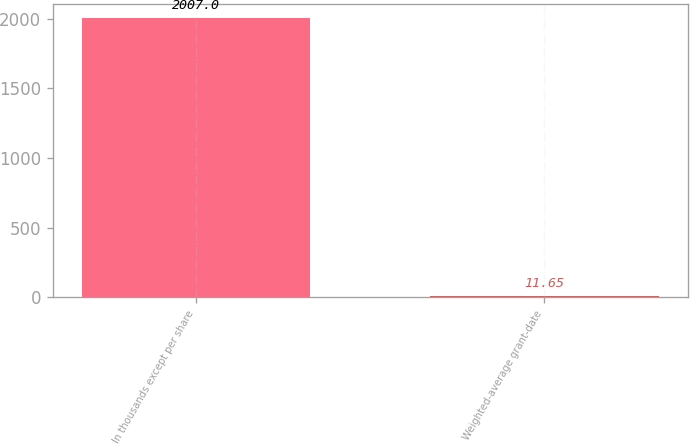Convert chart. <chart><loc_0><loc_0><loc_500><loc_500><bar_chart><fcel>In thousands except per share<fcel>Weighted-average grant-date<nl><fcel>2007<fcel>11.65<nl></chart> 